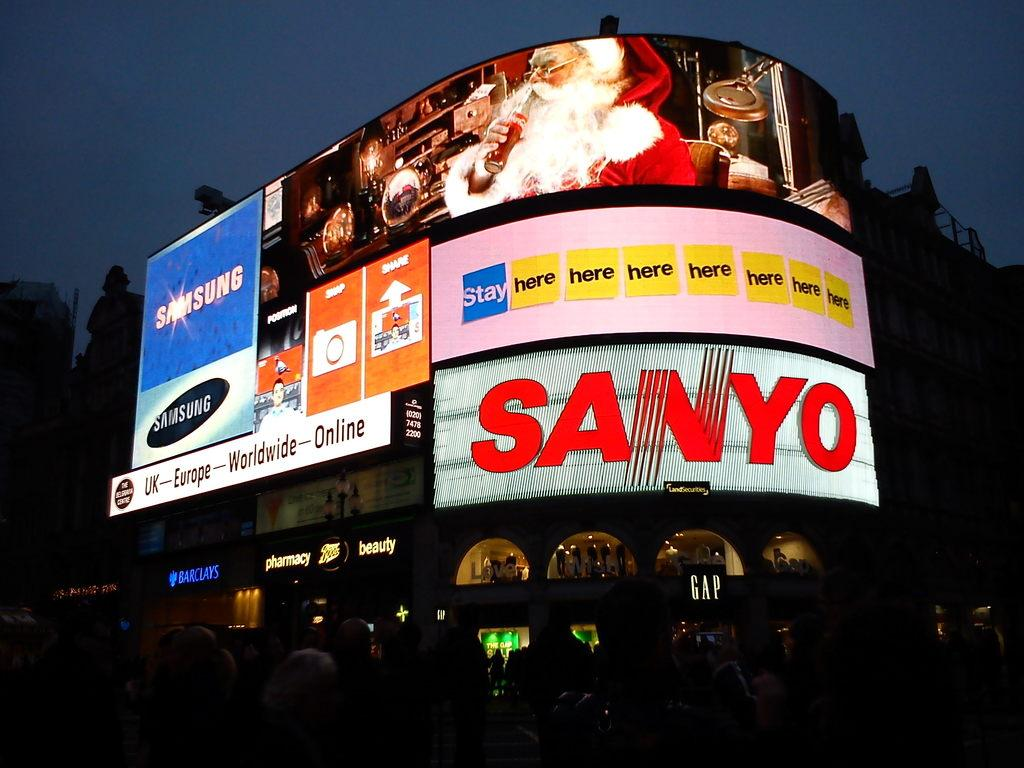Provide a one-sentence caption for the provided image. A Sanyo sign is lit up with a picture of Santa above. 